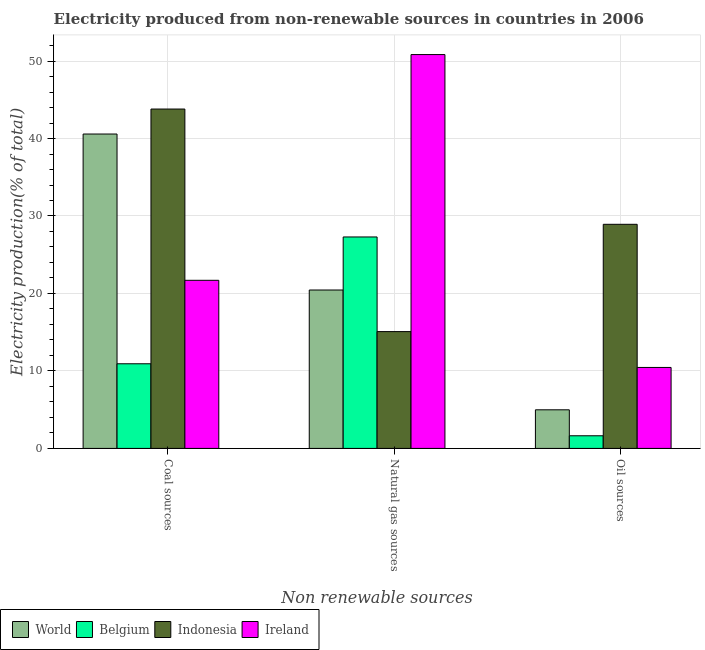How many groups of bars are there?
Provide a short and direct response. 3. Are the number of bars on each tick of the X-axis equal?
Offer a terse response. Yes. How many bars are there on the 2nd tick from the right?
Your answer should be very brief. 4. What is the label of the 2nd group of bars from the left?
Give a very brief answer. Natural gas sources. What is the percentage of electricity produced by natural gas in Ireland?
Your answer should be very brief. 50.84. Across all countries, what is the maximum percentage of electricity produced by oil sources?
Provide a short and direct response. 28.93. Across all countries, what is the minimum percentage of electricity produced by natural gas?
Your response must be concise. 15.08. In which country was the percentage of electricity produced by coal maximum?
Give a very brief answer. Indonesia. What is the total percentage of electricity produced by coal in the graph?
Your answer should be compact. 117.01. What is the difference between the percentage of electricity produced by natural gas in Indonesia and that in World?
Ensure brevity in your answer.  -5.37. What is the difference between the percentage of electricity produced by coal in Ireland and the percentage of electricity produced by natural gas in Belgium?
Make the answer very short. -5.59. What is the average percentage of electricity produced by oil sources per country?
Your answer should be very brief. 11.5. What is the difference between the percentage of electricity produced by natural gas and percentage of electricity produced by oil sources in Belgium?
Your response must be concise. 25.66. What is the ratio of the percentage of electricity produced by oil sources in World to that in Ireland?
Make the answer very short. 0.48. Is the percentage of electricity produced by natural gas in Indonesia less than that in Ireland?
Ensure brevity in your answer.  Yes. Is the difference between the percentage of electricity produced by coal in World and Ireland greater than the difference between the percentage of electricity produced by oil sources in World and Ireland?
Keep it short and to the point. Yes. What is the difference between the highest and the second highest percentage of electricity produced by coal?
Make the answer very short. 3.23. What is the difference between the highest and the lowest percentage of electricity produced by oil sources?
Make the answer very short. 27.3. Is the sum of the percentage of electricity produced by natural gas in Indonesia and World greater than the maximum percentage of electricity produced by oil sources across all countries?
Offer a terse response. Yes. What does the 1st bar from the left in Natural gas sources represents?
Give a very brief answer. World. What does the 1st bar from the right in Natural gas sources represents?
Give a very brief answer. Ireland. Is it the case that in every country, the sum of the percentage of electricity produced by coal and percentage of electricity produced by natural gas is greater than the percentage of electricity produced by oil sources?
Give a very brief answer. Yes. What is the difference between two consecutive major ticks on the Y-axis?
Give a very brief answer. 10. Are the values on the major ticks of Y-axis written in scientific E-notation?
Ensure brevity in your answer.  No. Does the graph contain any zero values?
Provide a short and direct response. No. Does the graph contain grids?
Your answer should be very brief. Yes. How many legend labels are there?
Make the answer very short. 4. What is the title of the graph?
Ensure brevity in your answer.  Electricity produced from non-renewable sources in countries in 2006. What is the label or title of the X-axis?
Ensure brevity in your answer.  Non renewable sources. What is the label or title of the Y-axis?
Give a very brief answer. Electricity production(% of total). What is the Electricity production(% of total) in World in Coal sources?
Your answer should be very brief. 40.58. What is the Electricity production(% of total) of Belgium in Coal sources?
Your answer should be compact. 10.93. What is the Electricity production(% of total) in Indonesia in Coal sources?
Provide a short and direct response. 43.81. What is the Electricity production(% of total) in Ireland in Coal sources?
Offer a terse response. 21.7. What is the Electricity production(% of total) in World in Natural gas sources?
Make the answer very short. 20.45. What is the Electricity production(% of total) in Belgium in Natural gas sources?
Provide a short and direct response. 27.29. What is the Electricity production(% of total) in Indonesia in Natural gas sources?
Your answer should be compact. 15.08. What is the Electricity production(% of total) of Ireland in Natural gas sources?
Offer a very short reply. 50.84. What is the Electricity production(% of total) of World in Oil sources?
Give a very brief answer. 4.98. What is the Electricity production(% of total) of Belgium in Oil sources?
Ensure brevity in your answer.  1.63. What is the Electricity production(% of total) of Indonesia in Oil sources?
Your answer should be compact. 28.93. What is the Electricity production(% of total) in Ireland in Oil sources?
Keep it short and to the point. 10.45. Across all Non renewable sources, what is the maximum Electricity production(% of total) of World?
Keep it short and to the point. 40.58. Across all Non renewable sources, what is the maximum Electricity production(% of total) of Belgium?
Ensure brevity in your answer.  27.29. Across all Non renewable sources, what is the maximum Electricity production(% of total) of Indonesia?
Your answer should be compact. 43.81. Across all Non renewable sources, what is the maximum Electricity production(% of total) of Ireland?
Keep it short and to the point. 50.84. Across all Non renewable sources, what is the minimum Electricity production(% of total) in World?
Make the answer very short. 4.98. Across all Non renewable sources, what is the minimum Electricity production(% of total) in Belgium?
Make the answer very short. 1.63. Across all Non renewable sources, what is the minimum Electricity production(% of total) in Indonesia?
Make the answer very short. 15.08. Across all Non renewable sources, what is the minimum Electricity production(% of total) of Ireland?
Your answer should be compact. 10.45. What is the total Electricity production(% of total) in World in the graph?
Your answer should be compact. 66.01. What is the total Electricity production(% of total) of Belgium in the graph?
Offer a terse response. 39.85. What is the total Electricity production(% of total) in Indonesia in the graph?
Make the answer very short. 87.81. What is the total Electricity production(% of total) in Ireland in the graph?
Make the answer very short. 82.99. What is the difference between the Electricity production(% of total) of World in Coal sources and that in Natural gas sources?
Your answer should be compact. 20.13. What is the difference between the Electricity production(% of total) of Belgium in Coal sources and that in Natural gas sources?
Keep it short and to the point. -16.37. What is the difference between the Electricity production(% of total) of Indonesia in Coal sources and that in Natural gas sources?
Keep it short and to the point. 28.73. What is the difference between the Electricity production(% of total) of Ireland in Coal sources and that in Natural gas sources?
Your answer should be compact. -29.14. What is the difference between the Electricity production(% of total) of World in Coal sources and that in Oil sources?
Keep it short and to the point. 35.6. What is the difference between the Electricity production(% of total) of Belgium in Coal sources and that in Oil sources?
Provide a short and direct response. 9.29. What is the difference between the Electricity production(% of total) in Indonesia in Coal sources and that in Oil sources?
Give a very brief answer. 14.88. What is the difference between the Electricity production(% of total) of Ireland in Coal sources and that in Oil sources?
Offer a terse response. 11.25. What is the difference between the Electricity production(% of total) in World in Natural gas sources and that in Oil sources?
Your answer should be very brief. 15.46. What is the difference between the Electricity production(% of total) of Belgium in Natural gas sources and that in Oil sources?
Ensure brevity in your answer.  25.66. What is the difference between the Electricity production(% of total) in Indonesia in Natural gas sources and that in Oil sources?
Make the answer very short. -13.85. What is the difference between the Electricity production(% of total) in Ireland in Natural gas sources and that in Oil sources?
Your answer should be compact. 40.39. What is the difference between the Electricity production(% of total) of World in Coal sources and the Electricity production(% of total) of Belgium in Natural gas sources?
Your answer should be compact. 13.29. What is the difference between the Electricity production(% of total) of World in Coal sources and the Electricity production(% of total) of Indonesia in Natural gas sources?
Give a very brief answer. 25.5. What is the difference between the Electricity production(% of total) in World in Coal sources and the Electricity production(% of total) in Ireland in Natural gas sources?
Your response must be concise. -10.26. What is the difference between the Electricity production(% of total) in Belgium in Coal sources and the Electricity production(% of total) in Indonesia in Natural gas sources?
Offer a very short reply. -4.15. What is the difference between the Electricity production(% of total) of Belgium in Coal sources and the Electricity production(% of total) of Ireland in Natural gas sources?
Your answer should be compact. -39.91. What is the difference between the Electricity production(% of total) of Indonesia in Coal sources and the Electricity production(% of total) of Ireland in Natural gas sources?
Your response must be concise. -7.03. What is the difference between the Electricity production(% of total) of World in Coal sources and the Electricity production(% of total) of Belgium in Oil sources?
Provide a succinct answer. 38.95. What is the difference between the Electricity production(% of total) of World in Coal sources and the Electricity production(% of total) of Indonesia in Oil sources?
Give a very brief answer. 11.65. What is the difference between the Electricity production(% of total) of World in Coal sources and the Electricity production(% of total) of Ireland in Oil sources?
Offer a very short reply. 30.13. What is the difference between the Electricity production(% of total) of Belgium in Coal sources and the Electricity production(% of total) of Indonesia in Oil sources?
Ensure brevity in your answer.  -18. What is the difference between the Electricity production(% of total) in Belgium in Coal sources and the Electricity production(% of total) in Ireland in Oil sources?
Provide a short and direct response. 0.47. What is the difference between the Electricity production(% of total) of Indonesia in Coal sources and the Electricity production(% of total) of Ireland in Oil sources?
Offer a terse response. 33.35. What is the difference between the Electricity production(% of total) of World in Natural gas sources and the Electricity production(% of total) of Belgium in Oil sources?
Provide a succinct answer. 18.82. What is the difference between the Electricity production(% of total) of World in Natural gas sources and the Electricity production(% of total) of Indonesia in Oil sources?
Ensure brevity in your answer.  -8.48. What is the difference between the Electricity production(% of total) in World in Natural gas sources and the Electricity production(% of total) in Ireland in Oil sources?
Your answer should be very brief. 10. What is the difference between the Electricity production(% of total) in Belgium in Natural gas sources and the Electricity production(% of total) in Indonesia in Oil sources?
Ensure brevity in your answer.  -1.63. What is the difference between the Electricity production(% of total) of Belgium in Natural gas sources and the Electricity production(% of total) of Ireland in Oil sources?
Offer a very short reply. 16.84. What is the difference between the Electricity production(% of total) in Indonesia in Natural gas sources and the Electricity production(% of total) in Ireland in Oil sources?
Your answer should be very brief. 4.63. What is the average Electricity production(% of total) of World per Non renewable sources?
Keep it short and to the point. 22. What is the average Electricity production(% of total) in Belgium per Non renewable sources?
Your response must be concise. 13.28. What is the average Electricity production(% of total) of Indonesia per Non renewable sources?
Provide a short and direct response. 29.27. What is the average Electricity production(% of total) of Ireland per Non renewable sources?
Offer a terse response. 27.66. What is the difference between the Electricity production(% of total) of World and Electricity production(% of total) of Belgium in Coal sources?
Offer a terse response. 29.65. What is the difference between the Electricity production(% of total) in World and Electricity production(% of total) in Indonesia in Coal sources?
Keep it short and to the point. -3.23. What is the difference between the Electricity production(% of total) in World and Electricity production(% of total) in Ireland in Coal sources?
Offer a very short reply. 18.88. What is the difference between the Electricity production(% of total) of Belgium and Electricity production(% of total) of Indonesia in Coal sources?
Keep it short and to the point. -32.88. What is the difference between the Electricity production(% of total) in Belgium and Electricity production(% of total) in Ireland in Coal sources?
Provide a short and direct response. -10.77. What is the difference between the Electricity production(% of total) of Indonesia and Electricity production(% of total) of Ireland in Coal sources?
Provide a succinct answer. 22.11. What is the difference between the Electricity production(% of total) of World and Electricity production(% of total) of Belgium in Natural gas sources?
Provide a succinct answer. -6.85. What is the difference between the Electricity production(% of total) in World and Electricity production(% of total) in Indonesia in Natural gas sources?
Provide a succinct answer. 5.37. What is the difference between the Electricity production(% of total) of World and Electricity production(% of total) of Ireland in Natural gas sources?
Make the answer very short. -30.39. What is the difference between the Electricity production(% of total) of Belgium and Electricity production(% of total) of Indonesia in Natural gas sources?
Provide a succinct answer. 12.22. What is the difference between the Electricity production(% of total) of Belgium and Electricity production(% of total) of Ireland in Natural gas sources?
Offer a terse response. -23.54. What is the difference between the Electricity production(% of total) in Indonesia and Electricity production(% of total) in Ireland in Natural gas sources?
Your answer should be very brief. -35.76. What is the difference between the Electricity production(% of total) of World and Electricity production(% of total) of Belgium in Oil sources?
Ensure brevity in your answer.  3.35. What is the difference between the Electricity production(% of total) in World and Electricity production(% of total) in Indonesia in Oil sources?
Provide a short and direct response. -23.94. What is the difference between the Electricity production(% of total) of World and Electricity production(% of total) of Ireland in Oil sources?
Ensure brevity in your answer.  -5.47. What is the difference between the Electricity production(% of total) in Belgium and Electricity production(% of total) in Indonesia in Oil sources?
Make the answer very short. -27.3. What is the difference between the Electricity production(% of total) of Belgium and Electricity production(% of total) of Ireland in Oil sources?
Provide a short and direct response. -8.82. What is the difference between the Electricity production(% of total) in Indonesia and Electricity production(% of total) in Ireland in Oil sources?
Your response must be concise. 18.48. What is the ratio of the Electricity production(% of total) of World in Coal sources to that in Natural gas sources?
Provide a succinct answer. 1.98. What is the ratio of the Electricity production(% of total) of Belgium in Coal sources to that in Natural gas sources?
Give a very brief answer. 0.4. What is the ratio of the Electricity production(% of total) of Indonesia in Coal sources to that in Natural gas sources?
Give a very brief answer. 2.91. What is the ratio of the Electricity production(% of total) of Ireland in Coal sources to that in Natural gas sources?
Keep it short and to the point. 0.43. What is the ratio of the Electricity production(% of total) in World in Coal sources to that in Oil sources?
Make the answer very short. 8.14. What is the ratio of the Electricity production(% of total) of Belgium in Coal sources to that in Oil sources?
Your answer should be compact. 6.69. What is the ratio of the Electricity production(% of total) in Indonesia in Coal sources to that in Oil sources?
Provide a succinct answer. 1.51. What is the ratio of the Electricity production(% of total) of Ireland in Coal sources to that in Oil sources?
Keep it short and to the point. 2.08. What is the ratio of the Electricity production(% of total) of World in Natural gas sources to that in Oil sources?
Keep it short and to the point. 4.1. What is the ratio of the Electricity production(% of total) of Belgium in Natural gas sources to that in Oil sources?
Your answer should be very brief. 16.72. What is the ratio of the Electricity production(% of total) in Indonesia in Natural gas sources to that in Oil sources?
Offer a terse response. 0.52. What is the ratio of the Electricity production(% of total) of Ireland in Natural gas sources to that in Oil sources?
Make the answer very short. 4.86. What is the difference between the highest and the second highest Electricity production(% of total) in World?
Give a very brief answer. 20.13. What is the difference between the highest and the second highest Electricity production(% of total) of Belgium?
Offer a terse response. 16.37. What is the difference between the highest and the second highest Electricity production(% of total) of Indonesia?
Offer a very short reply. 14.88. What is the difference between the highest and the second highest Electricity production(% of total) of Ireland?
Provide a succinct answer. 29.14. What is the difference between the highest and the lowest Electricity production(% of total) of World?
Your answer should be very brief. 35.6. What is the difference between the highest and the lowest Electricity production(% of total) of Belgium?
Your answer should be very brief. 25.66. What is the difference between the highest and the lowest Electricity production(% of total) in Indonesia?
Your answer should be very brief. 28.73. What is the difference between the highest and the lowest Electricity production(% of total) in Ireland?
Offer a terse response. 40.39. 